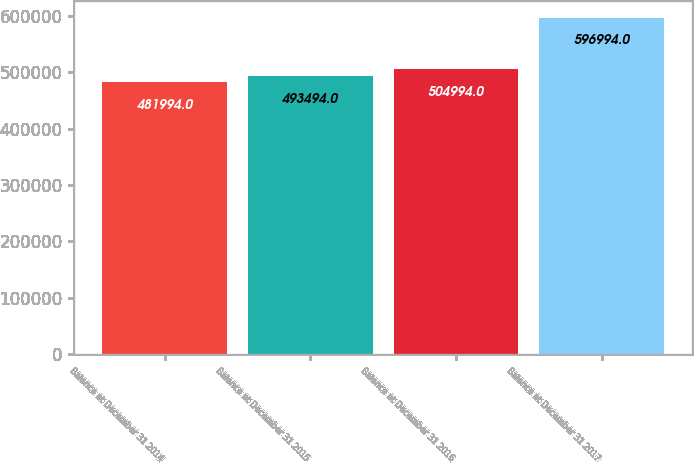Convert chart to OTSL. <chart><loc_0><loc_0><loc_500><loc_500><bar_chart><fcel>Balance at December 31 2014<fcel>Balance at December 31 2015<fcel>Balance at December 31 2016<fcel>Balance at December 31 2017<nl><fcel>481994<fcel>493494<fcel>504994<fcel>596994<nl></chart> 